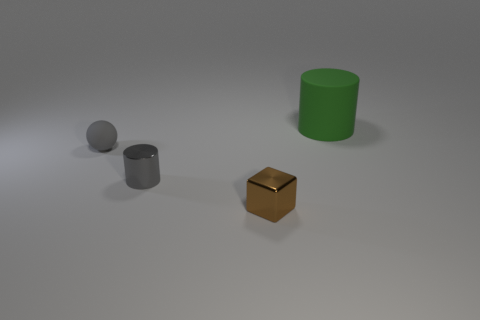Subtract all green cylinders. How many cylinders are left? 1 Subtract 1 cylinders. How many cylinders are left? 1 Add 2 cylinders. How many objects exist? 6 Subtract all cyan balls. How many green cylinders are left? 1 Subtract all cubes. How many objects are left? 3 Subtract all big rubber cylinders. Subtract all green cylinders. How many objects are left? 2 Add 1 gray objects. How many gray objects are left? 3 Add 2 spheres. How many spheres exist? 3 Subtract 0 blue blocks. How many objects are left? 4 Subtract all blue cylinders. Subtract all red spheres. How many cylinders are left? 2 